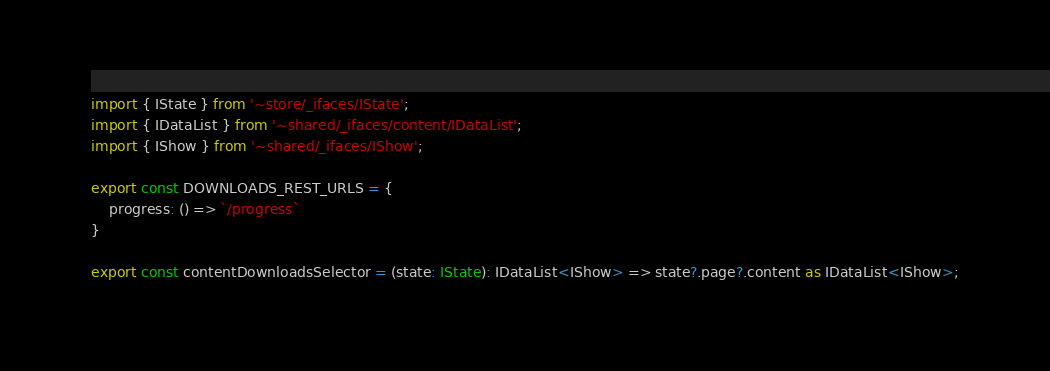Convert code to text. <code><loc_0><loc_0><loc_500><loc_500><_TypeScript_>import { IState } from '~store/_ifaces/IState';
import { IDataList } from '~shared/_ifaces/content/IDataList';
import { IShow } from '~shared/_ifaces/IShow';

export const DOWNLOADS_REST_URLS = {
	progress: () => `/progress`
}

export const contentDownloadsSelector = (state: IState): IDataList<IShow> => state?.page?.content as IDataList<IShow>;</code> 